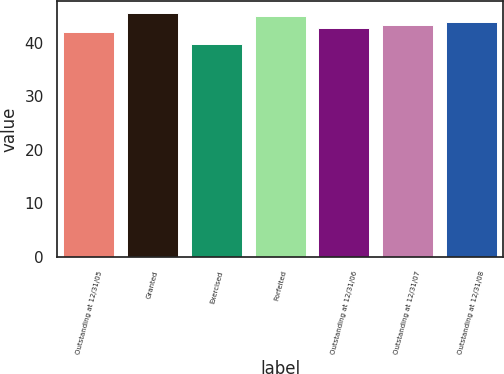Convert chart. <chart><loc_0><loc_0><loc_500><loc_500><bar_chart><fcel>Outstanding at 12/31/05<fcel>Granted<fcel>Exercised<fcel>Forfeited<fcel>Outstanding at 12/31/06<fcel>Outstanding at 12/31/07<fcel>Outstanding at 12/31/08<nl><fcel>42<fcel>45.55<fcel>39.8<fcel>45.01<fcel>42.84<fcel>43.38<fcel>43.92<nl></chart> 